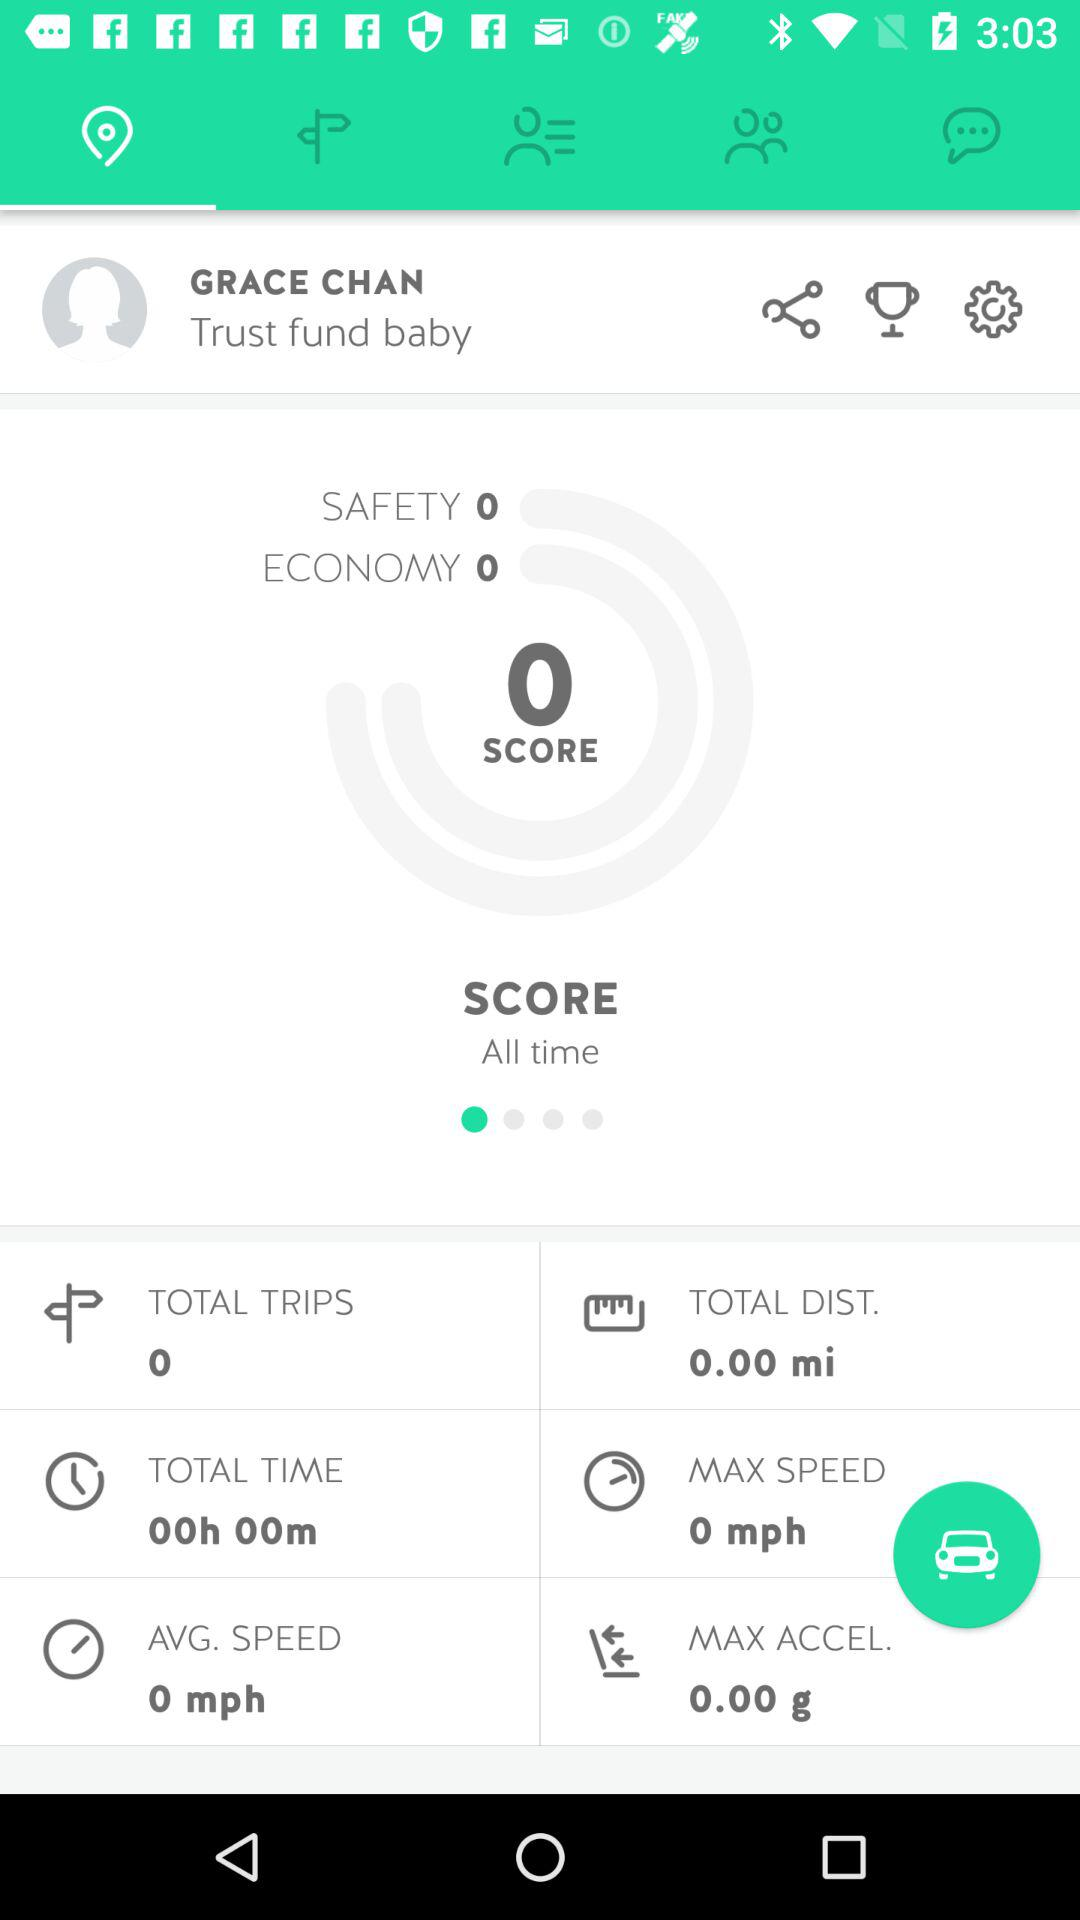What is the average speed of all time?
Answer the question using a single word or phrase. 0 mph 